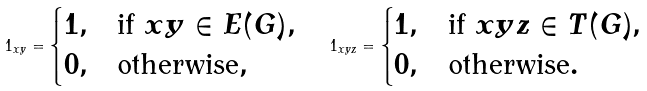Convert formula to latex. <formula><loc_0><loc_0><loc_500><loc_500>1 _ { x y } = \begin{cases} 1 , & \text {if $xy\in E(G)$} , \\ 0 , & \text {otherwise} , \end{cases} \quad 1 _ { x y z } = \begin{cases} 1 , & \text {if $xyz\in T(G)$} , \\ 0 , & \text {otherwise} . \end{cases}</formula> 